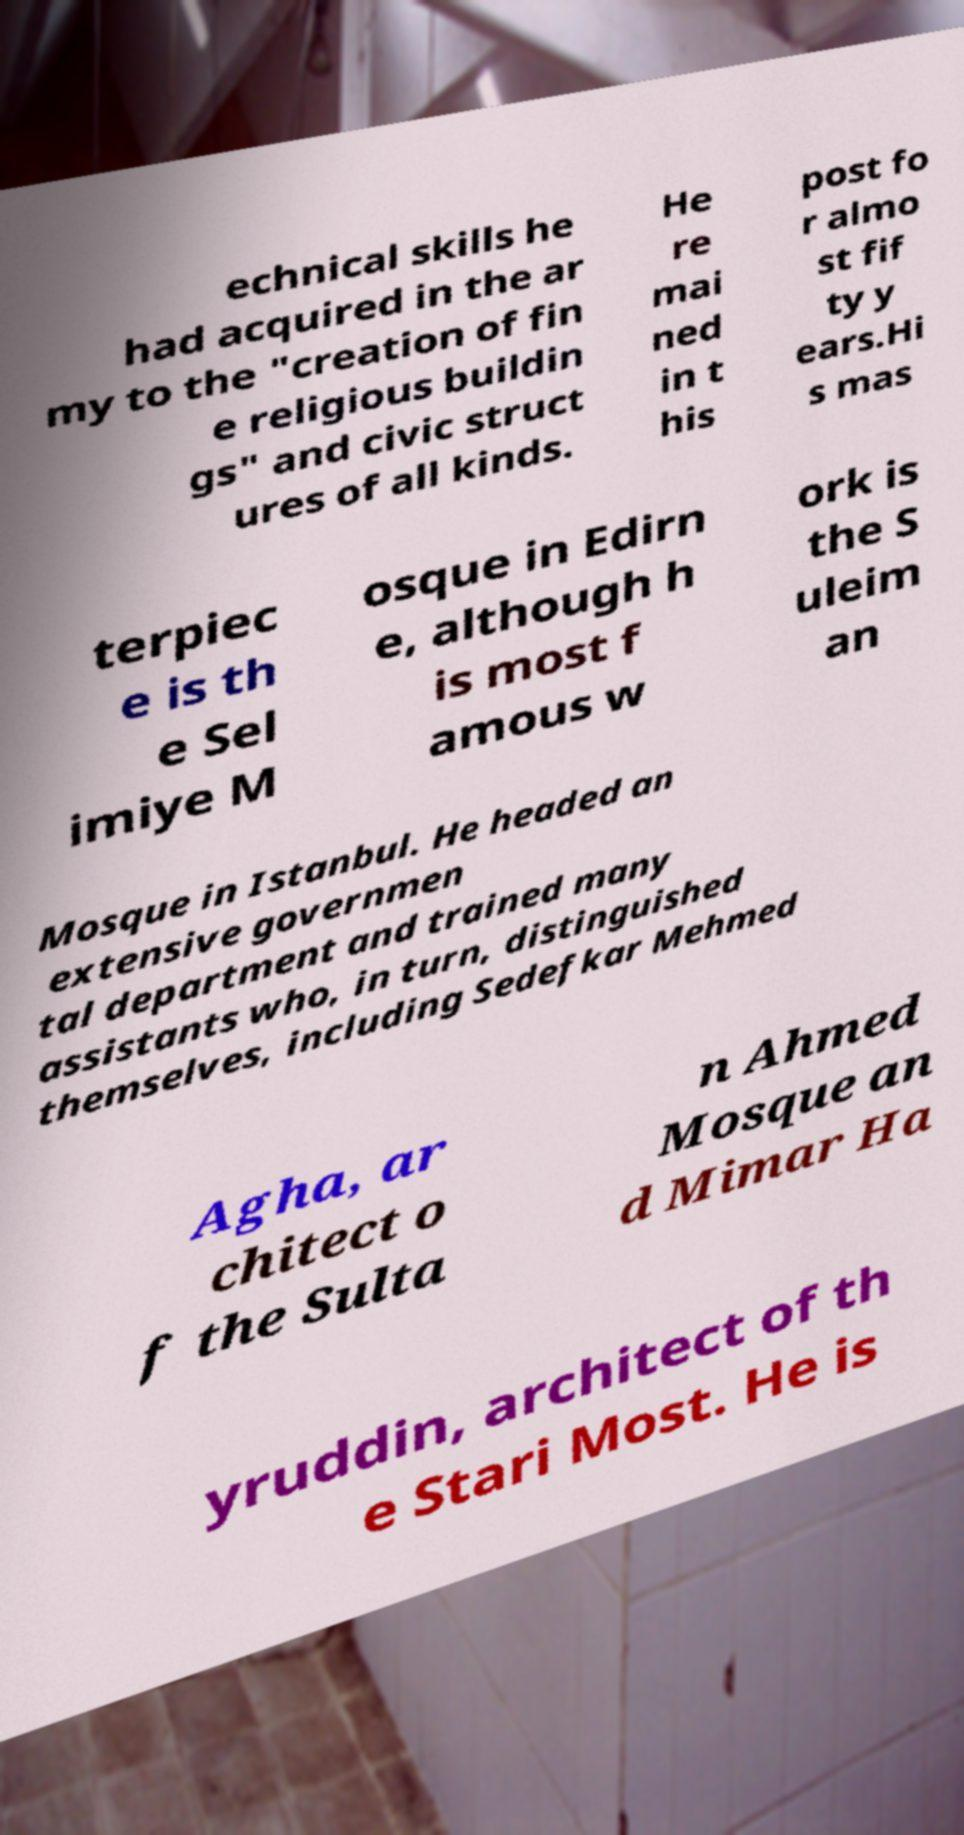Please read and relay the text visible in this image. What does it say? echnical skills he had acquired in the ar my to the "creation of fin e religious buildin gs" and civic struct ures of all kinds. He re mai ned in t his post fo r almo st fif ty y ears.Hi s mas terpiec e is th e Sel imiye M osque in Edirn e, although h is most f amous w ork is the S uleim an Mosque in Istanbul. He headed an extensive governmen tal department and trained many assistants who, in turn, distinguished themselves, including Sedefkar Mehmed Agha, ar chitect o f the Sulta n Ahmed Mosque an d Mimar Ha yruddin, architect of th e Stari Most. He is 